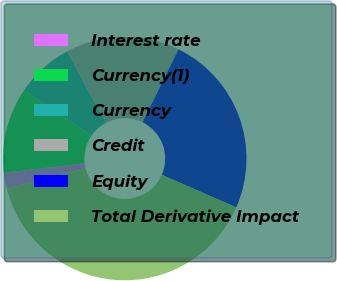Convert chart to OTSL. <chart><loc_0><loc_0><loc_500><loc_500><pie_chart><fcel>Interest rate<fcel>Currency(1)<fcel>Currency<fcel>Credit<fcel>Equity<fcel>Total Derivative Impact<nl><fcel>2.1%<fcel>11.38%<fcel>7.65%<fcel>15.12%<fcel>24.3%<fcel>39.45%<nl></chart> 